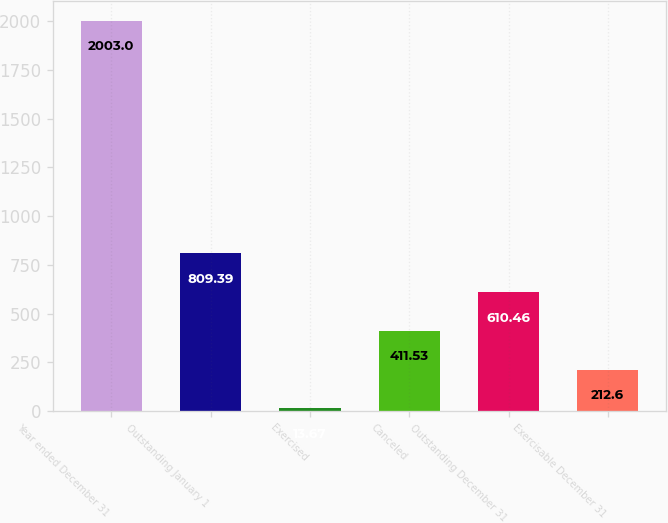Convert chart to OTSL. <chart><loc_0><loc_0><loc_500><loc_500><bar_chart><fcel>Year ended December 31<fcel>Outstanding January 1<fcel>Exercised<fcel>Canceled<fcel>Outstanding December 31<fcel>Exercisable December 31<nl><fcel>2003<fcel>809.39<fcel>13.67<fcel>411.53<fcel>610.46<fcel>212.6<nl></chart> 